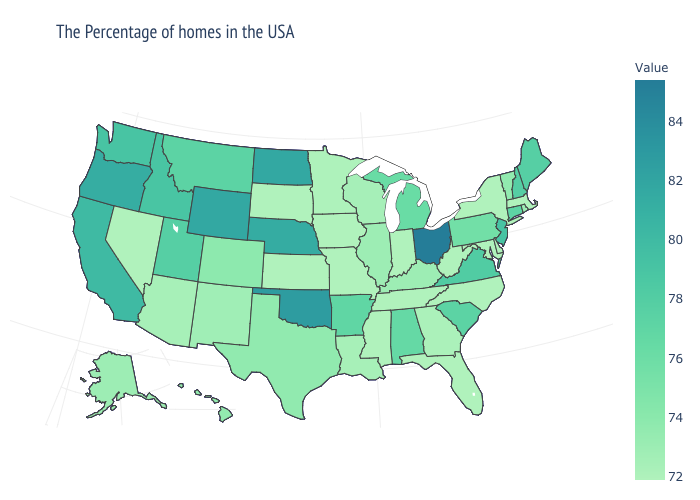Does Ohio have the highest value in the USA?
Write a very short answer. Yes. Does Georgia have the lowest value in the South?
Answer briefly. No. Does Alaska have a higher value than Alabama?
Answer briefly. No. Among the states that border Kansas , does Oklahoma have the highest value?
Short answer required. Yes. 